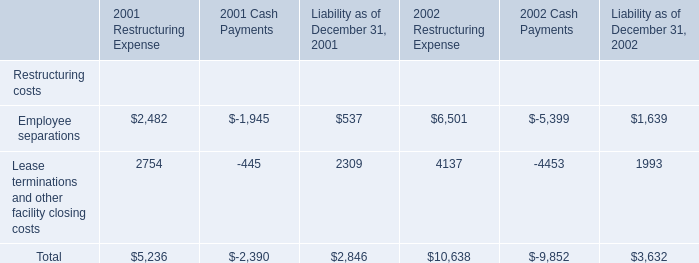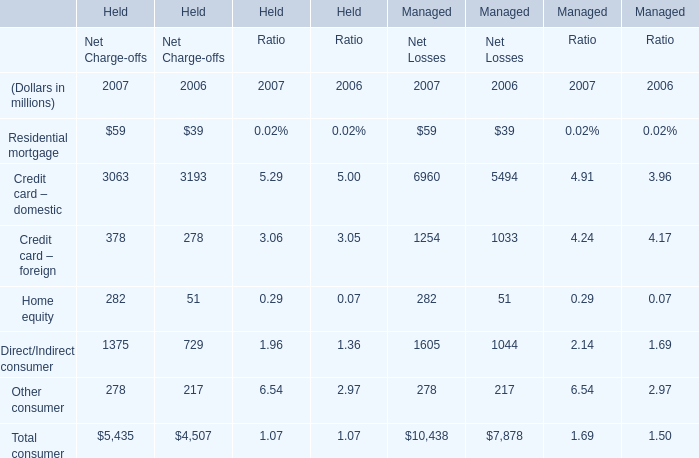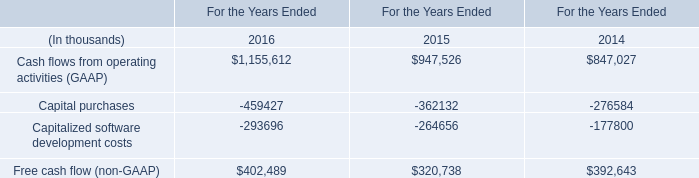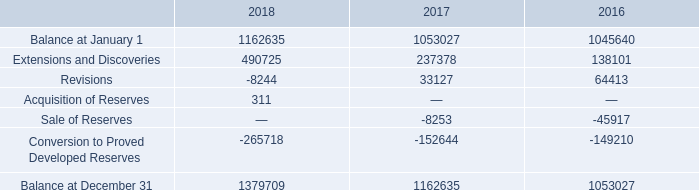what's the total amount of Conversion to Proved Developed Reserves of 2018, Capital purchases of For the Years Ended 2015, and Capitalized software development costs of For the Years Ended 2014 ? 
Computations: ((265718.0 + 362132.0) + 177800.0)
Answer: 805650.0. 